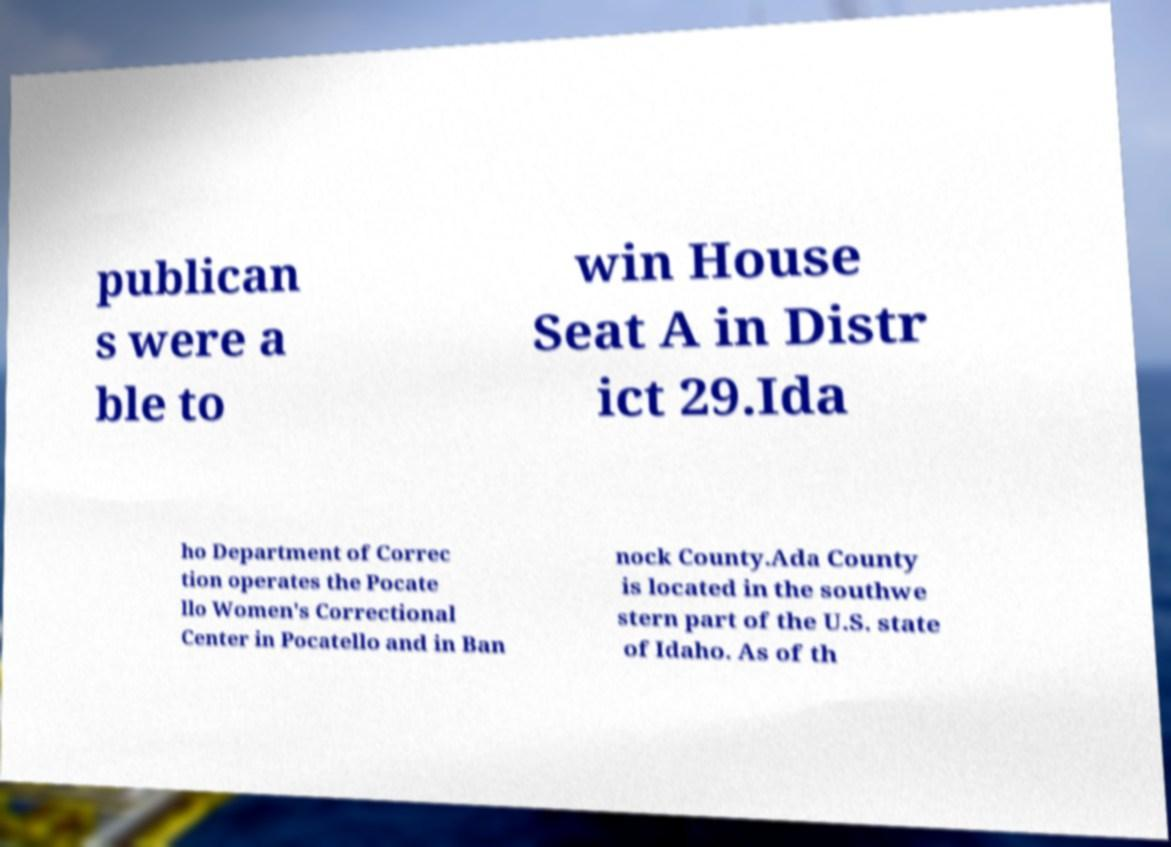Please identify and transcribe the text found in this image. publican s were a ble to win House Seat A in Distr ict 29.Ida ho Department of Correc tion operates the Pocate llo Women's Correctional Center in Pocatello and in Ban nock County.Ada County is located in the southwe stern part of the U.S. state of Idaho. As of th 